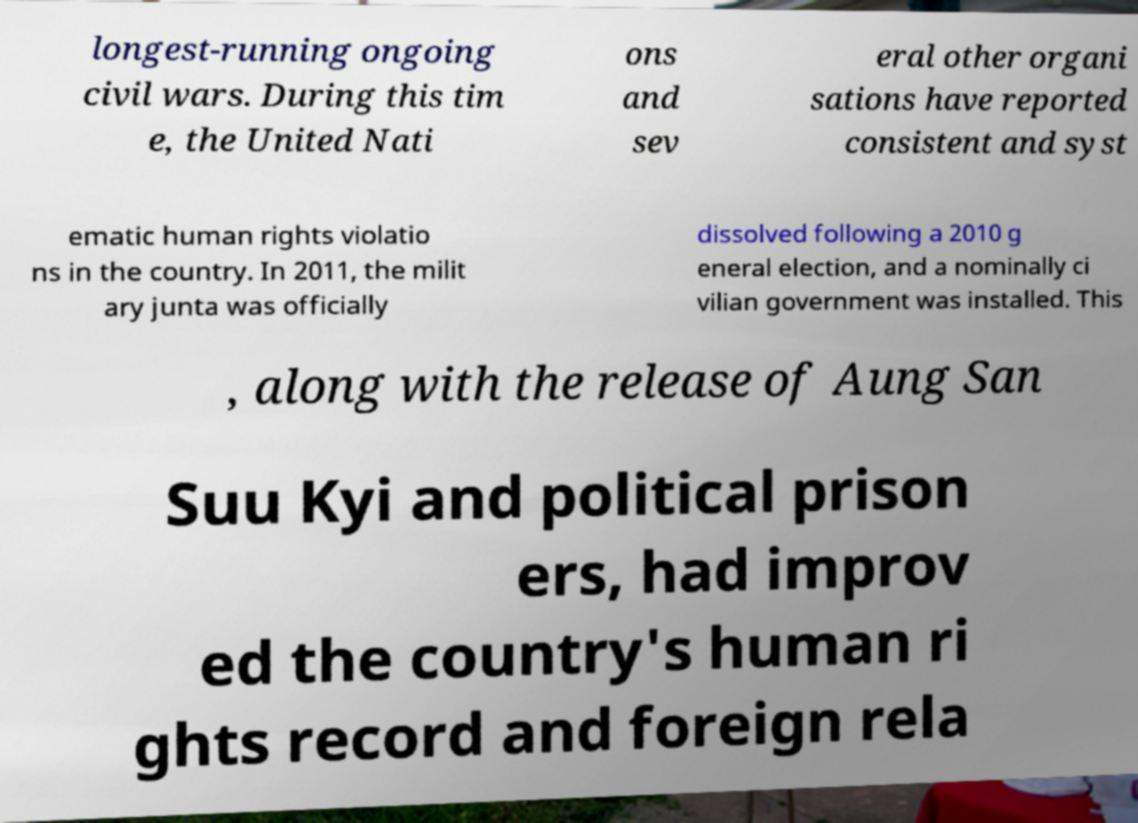Can you accurately transcribe the text from the provided image for me? longest-running ongoing civil wars. During this tim e, the United Nati ons and sev eral other organi sations have reported consistent and syst ematic human rights violatio ns in the country. In 2011, the milit ary junta was officially dissolved following a 2010 g eneral election, and a nominally ci vilian government was installed. This , along with the release of Aung San Suu Kyi and political prison ers, had improv ed the country's human ri ghts record and foreign rela 